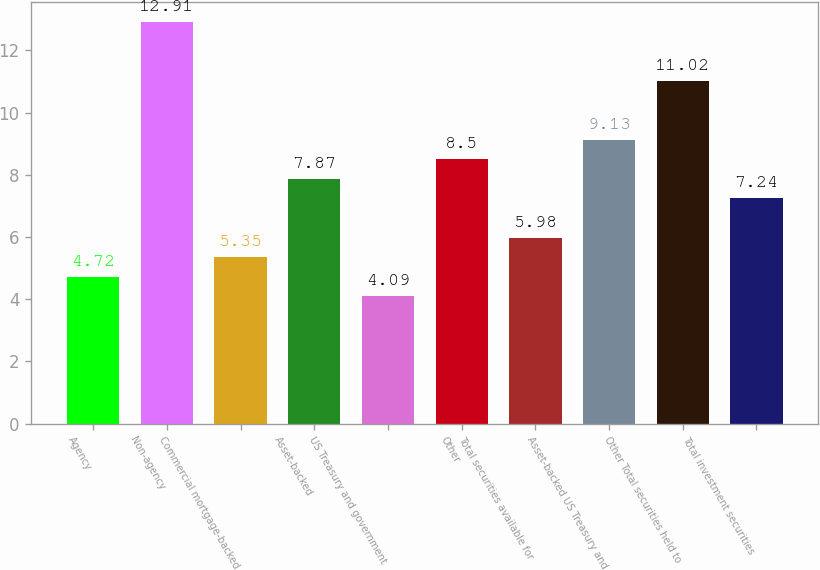<chart> <loc_0><loc_0><loc_500><loc_500><bar_chart><fcel>Agency<fcel>Non-agency<fcel>Commercial mortgage-backed<fcel>Asset-backed<fcel>US Treasury and government<fcel>Other<fcel>Total securities available for<fcel>Asset-backed US Treasury and<fcel>Other Total securities held to<fcel>Total investment securities<nl><fcel>4.72<fcel>12.91<fcel>5.35<fcel>7.87<fcel>4.09<fcel>8.5<fcel>5.98<fcel>9.13<fcel>11.02<fcel>7.24<nl></chart> 